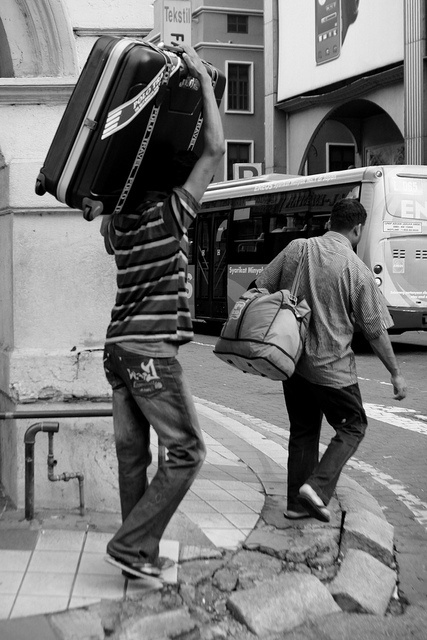Describe the objects in this image and their specific colors. I can see people in darkgray, black, gray, and lightgray tones, bus in darkgray, black, lightgray, and gray tones, people in darkgray, black, gray, and lightgray tones, suitcase in darkgray, black, gray, and lightgray tones, and handbag in darkgray, gray, black, and lightgray tones in this image. 